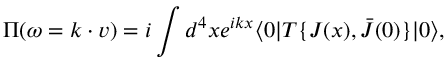<formula> <loc_0><loc_0><loc_500><loc_500>\Pi ( \omega = k \cdot v ) = i \int d ^ { 4 } x e ^ { i k x } \langle 0 | T \{ J ( x ) , \bar { J } ( 0 ) \} | 0 \rangle ,</formula> 